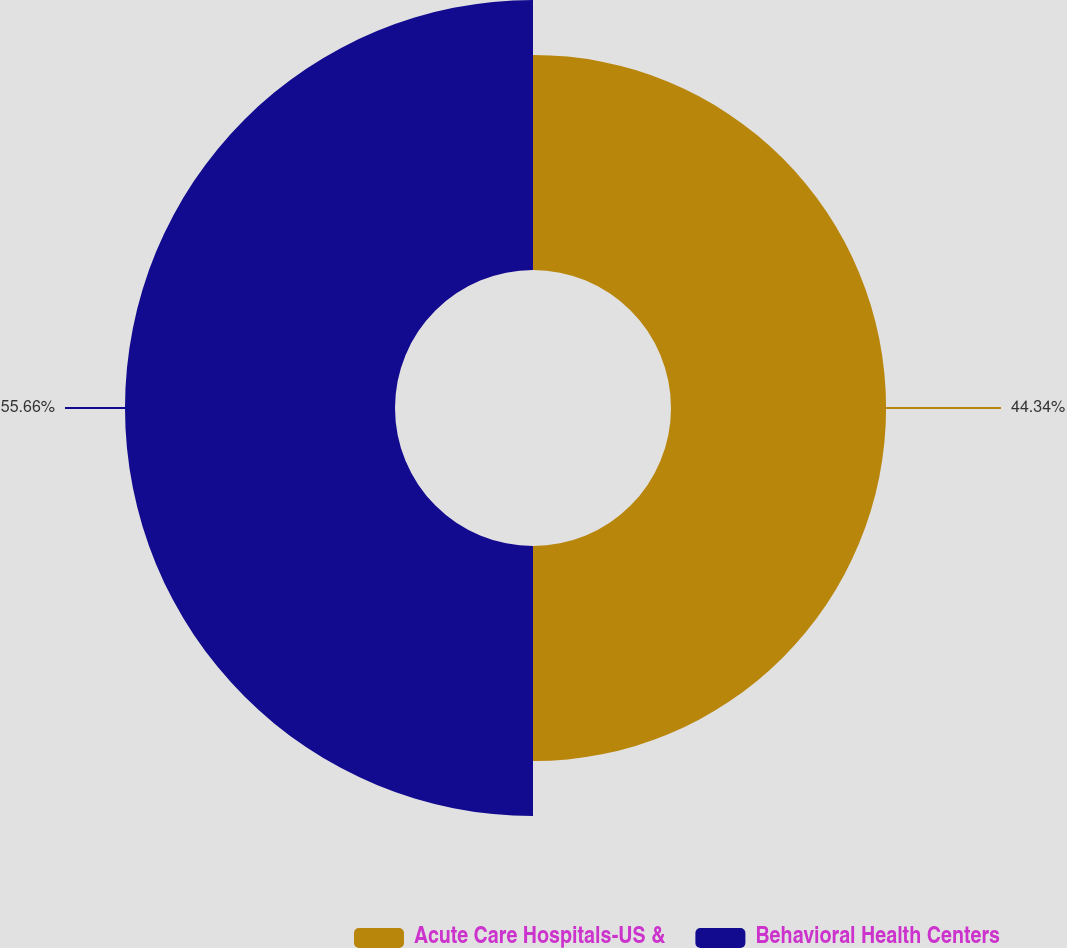Convert chart to OTSL. <chart><loc_0><loc_0><loc_500><loc_500><pie_chart><fcel>Acute Care Hospitals-US &<fcel>Behavioral Health Centers<nl><fcel>44.34%<fcel>55.66%<nl></chart> 